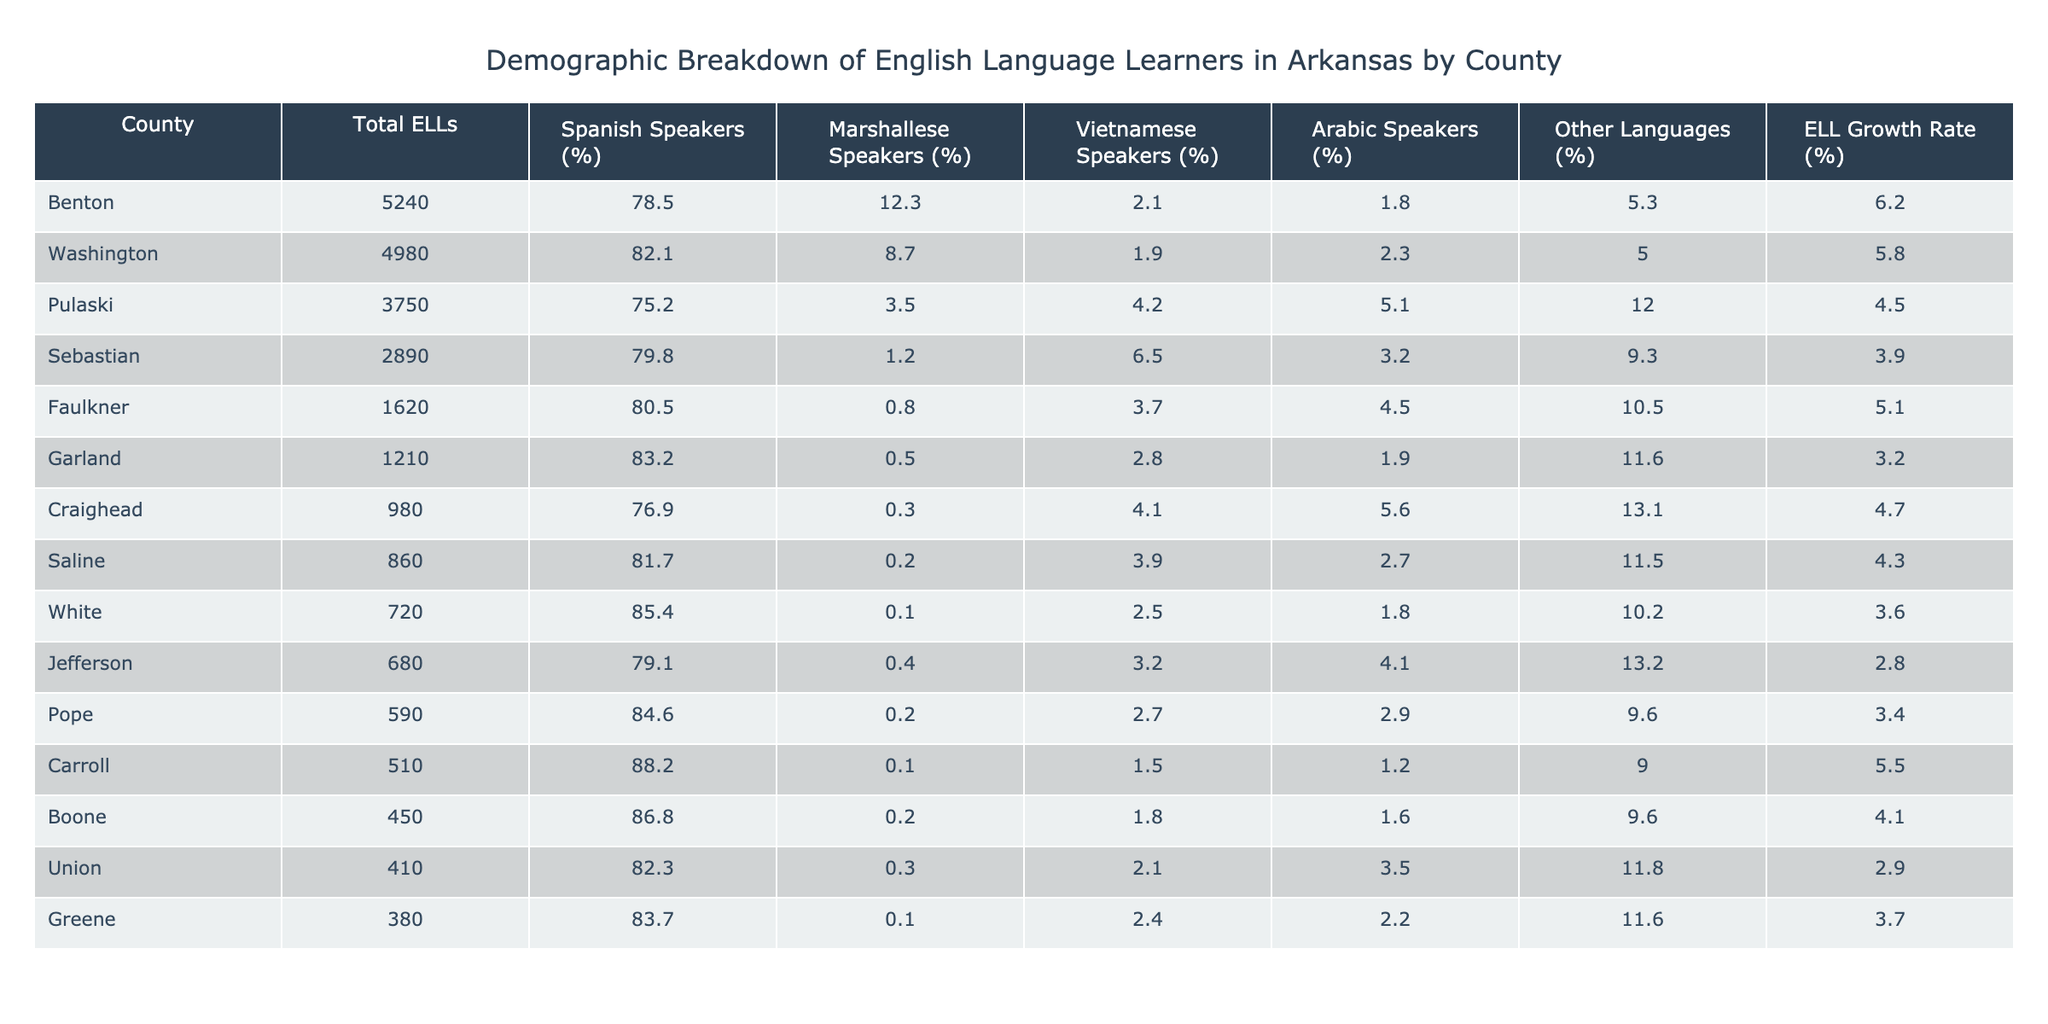What's the total number of English Language Learners in Benton County? The table shows that Benton County has a total of 5240 English Language Learners.
Answer: 5240 Which county has the highest percentage of Spanish speakers among English Language Learners? The table indicates that Carroll County has the highest percentage of Spanish speakers at 88.2%.
Answer: Carroll What is the ELL growth rate for Washington County? Washington County's ELL growth rate, as per the table, is 5.8%.
Answer: 5.8% Which county has the lowest total ELLs and what is that number? The table lists Greene County with the lowest total ELLs at 380.
Answer: 380 What percentage of English Language Learners in Pulaski County speak Arabic? The table indicates that 5.1% of English Language Learners in Pulaski County speak Arabic.
Answer: 5.1% Is the percentage of Marshallese speakers in Saline County greater than 1%? According to the table, Saline County has only 0.2% Marshallese speakers, which is not greater than 1%.
Answer: No What is the difference in total ELLs between Benton County and Sebastian County? Benton County has 5240 ELLs and Sebastian County has 2890. The difference is calculated as 5240 - 2890 = 2350.
Answer: 2350 What is the combined percentage of speakers of other languages in Faulkner and Garland Counties? From the table, Faulkner County has 10.5% for other languages and Garland County has 11.6%. Adding these gives 10.5 + 11.6 = 22.1%.
Answer: 22.1% Which county has a higher ELL growth rate, Pope or Jefferson? The ELL growth rate for Pope County is 3.4% and for Jefferson County it is 2.8%. Since 3.4% > 2.8%, Pope County has the higher growth rate.
Answer: Pope What is the most common language spoken among ELLs in Sebastian County? The table shows that in Sebastian County, 79.8% of ELLs are Spanish speakers, making it the most common language.
Answer: Spanish Which counties have more than 4000 English Language Learners? The counties with more than 4000 ELLs are Benton (5240), Washington (4980), and Pulaski (3750).
Answer: Benton, Washington Which county has the lowest percentage of Arabic speakers? The table shows that Garland County has the lowest percentage at 1.9%.
Answer: Garland 